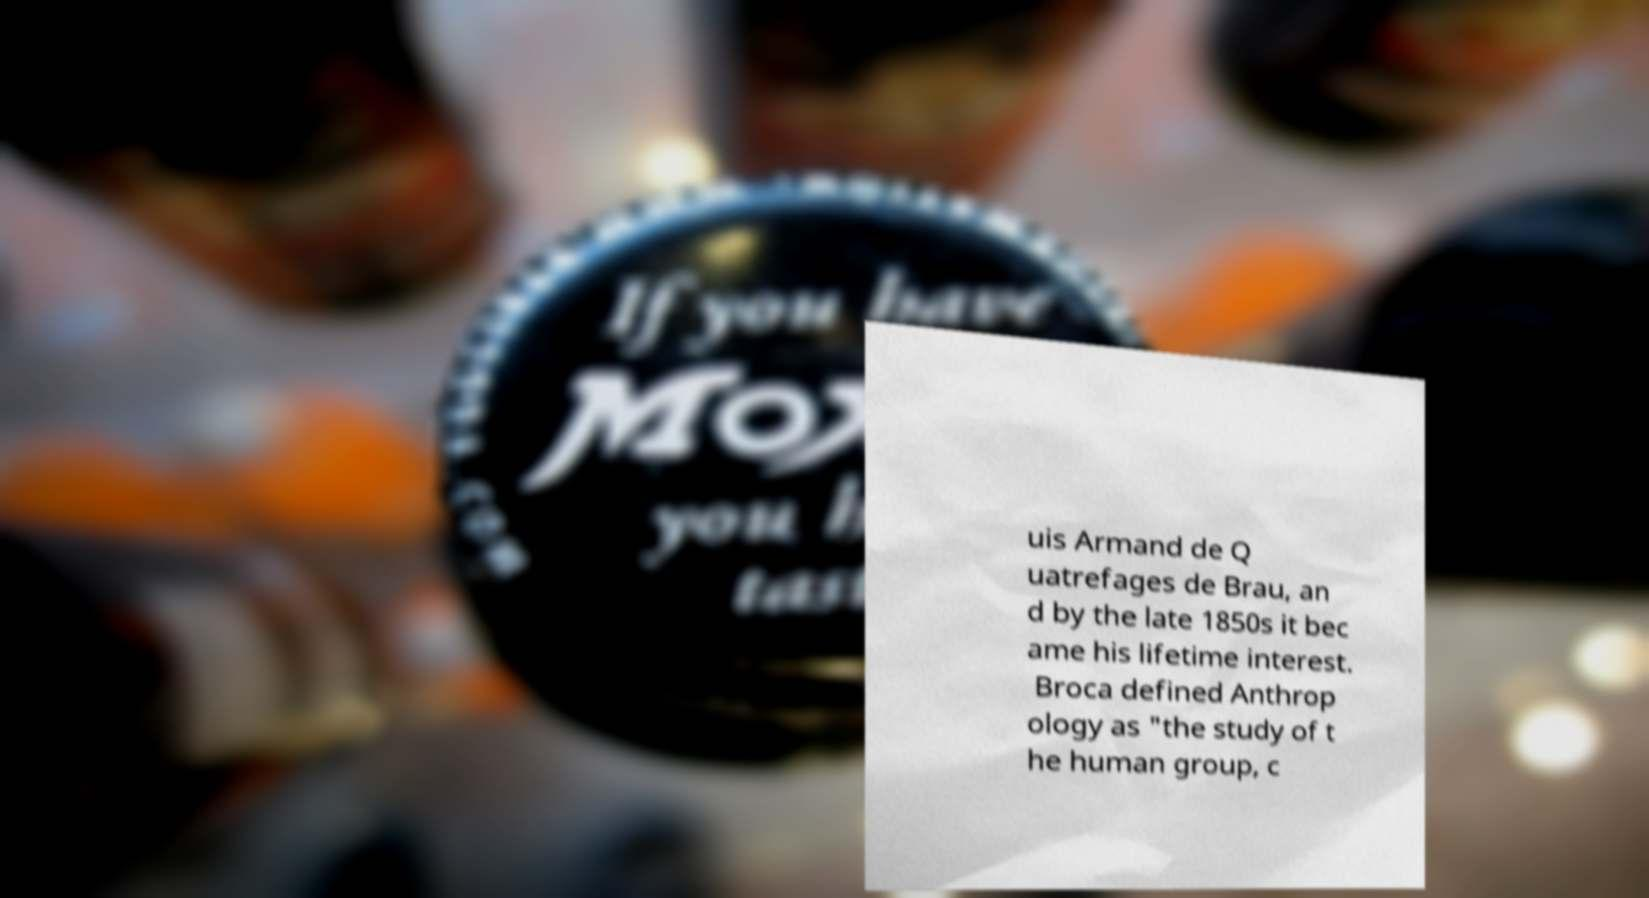Can you accurately transcribe the text from the provided image for me? uis Armand de Q uatrefages de Brau, an d by the late 1850s it bec ame his lifetime interest. Broca defined Anthrop ology as "the study of t he human group, c 